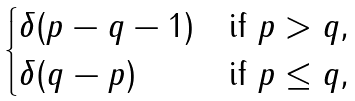Convert formula to latex. <formula><loc_0><loc_0><loc_500><loc_500>\begin{cases} \delta ( p - q - 1 ) & \text {if $p > q$,} \\ \delta ( q - p ) & \text {if $p \leq q$,} \end{cases}</formula> 